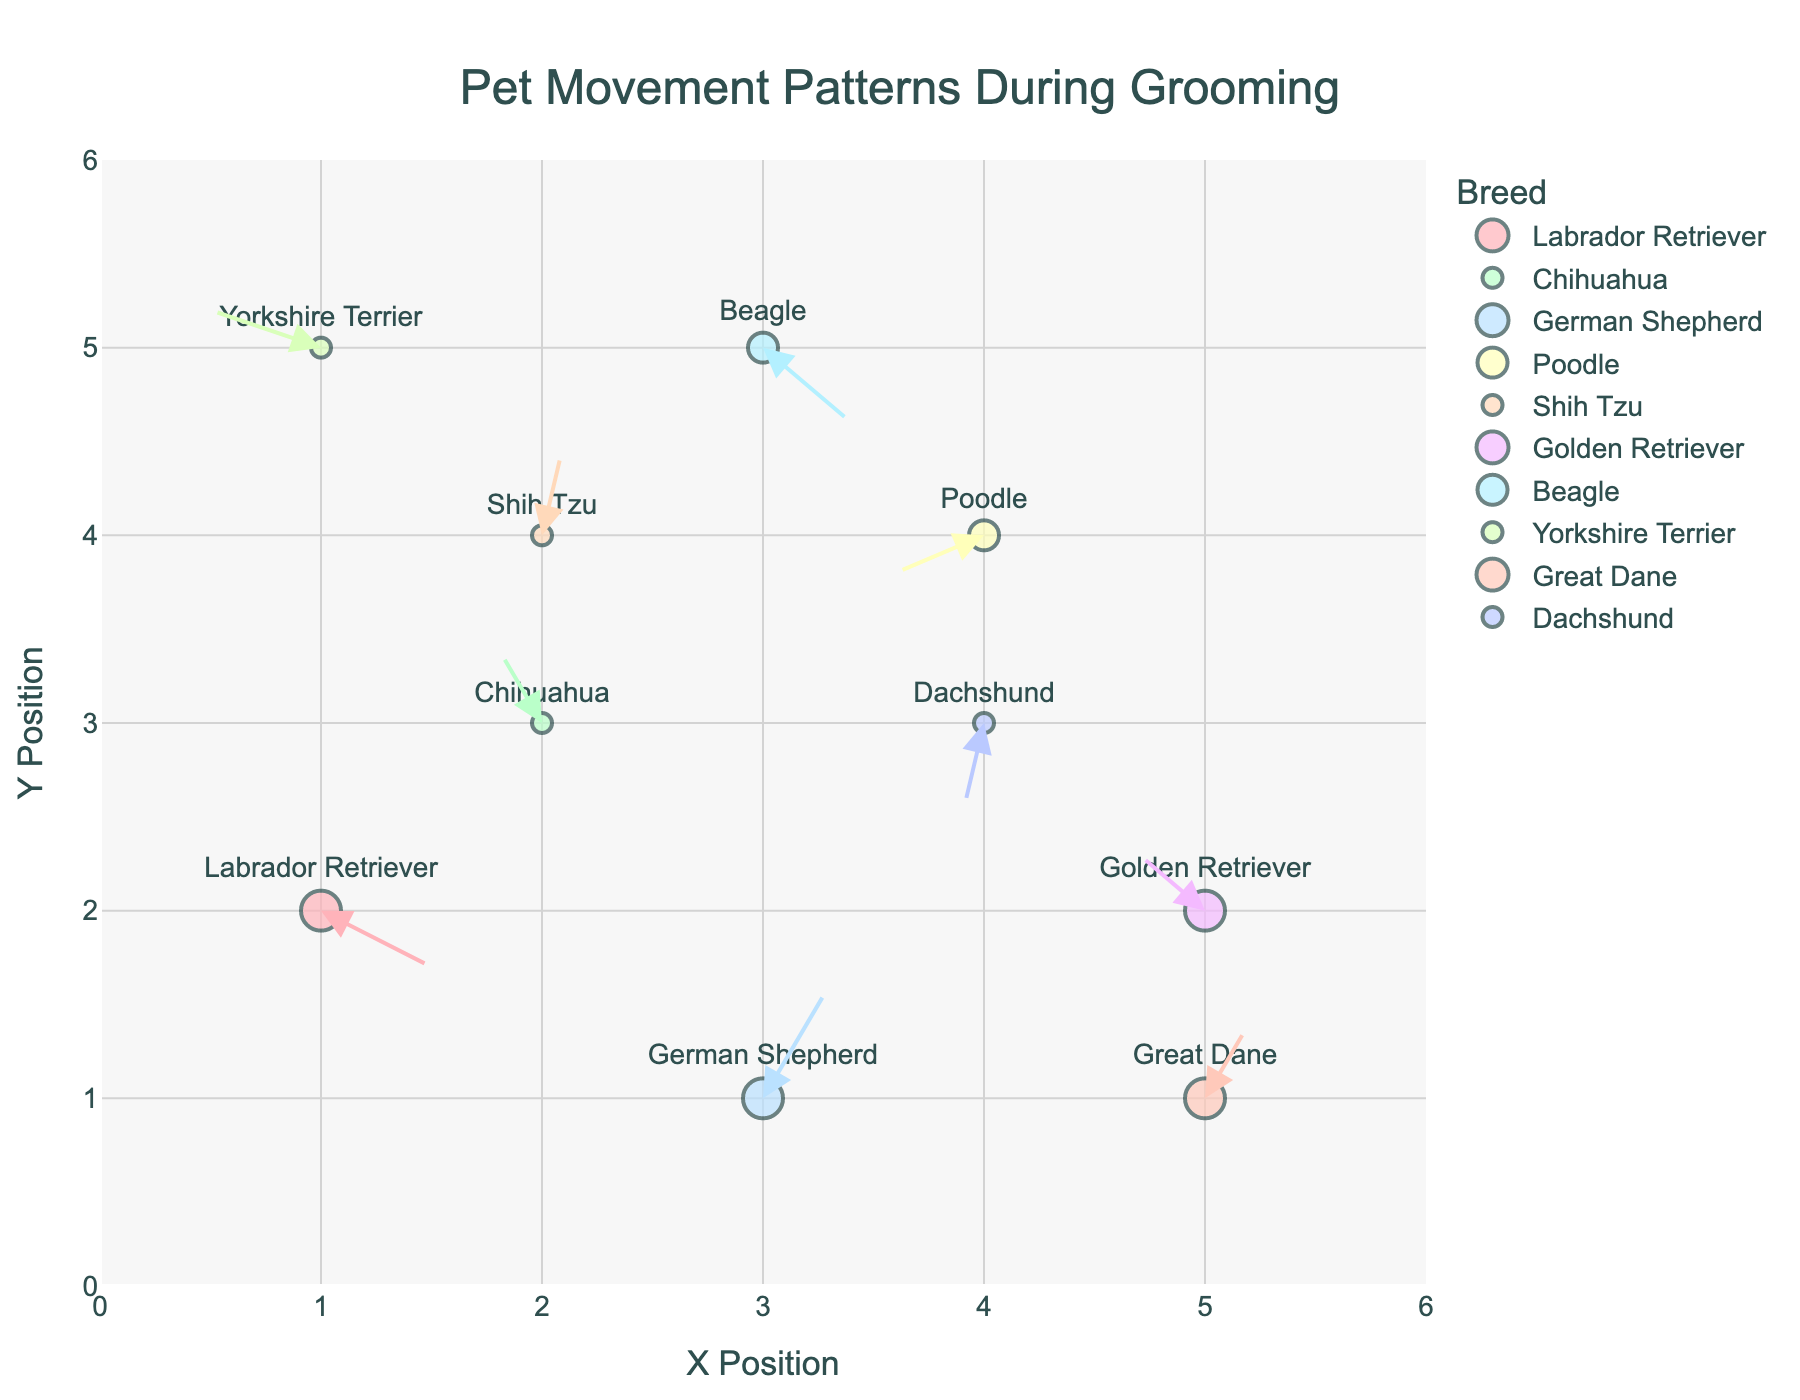How many breeds are represented in the plot? The figure includes a legend that lists each breed, and there are distinct colors for each breed. Counting the unique breeds listed in the legend gives us this answer.
Answer: 10 Which breed has the largest marker size and what is it? In the figure, the marker sizes correspond to pet sizes (Small, Medium, Large). The legend shows different sizes and the breed associated with each size. The breed with the largest marker size, corresponding to "Large", needs to be identified.
Answer: Labrador Retriever, German Shepherd, Golden Retriever, Great Dane What is the movement pattern of the Shih Tzu from its initial position? Locate the Shih Tzu on the plot marked with its breed name. From the initial position, trace the quiver arrow to see its endpoint direction and distance. This will reveal the movement pattern.
Answer: (2, 4) to (2.1, 4.5) Which breed shows the least movement, and how can you tell? By looking at the length of quiver arrows for each breed, the breed with the shortest arrow indicates the least movement. Measure or visually compare the sizes of arrows.
Answer: Dachshund Which breeds are positioned at coordinate (5, 2) and (5, 1)? Locate the coordinates (5, 2) and (5, 1) on the X and Y axes in the plot. Identify which breeds are marked at these positions.
Answer: Golden Retriever at (5, 2) and Great Dane at (5, 1) How many distinct points do pets start from in the plot? Each data point is represented by a unique marker on the plot. Count the individual markers to find the total number of distinct starting points.
Answer: 10 Compare the movement direction of the Chihuahua and the Beagle; how do they differ? Find the initial positions of the Chihuahua and Beagle on the plot. Trace their movement arrows to identify their directions and compare them.
Answer: Chihuahua moves up-right, Beagle moves down-left What is the combined movement vector for the German Shepherd and the Great Dane? Identify the initial coordinates and movement vectors for both breeds. Add their vector components (u, v) to get the combined vector. German Shepherd: (3, 1) + (0.3, 0.6); Great Dane: (5, 1) + (0.2, 0.4). Combined vector: (0.3 + 0.2, 0.6 + 0.4) = (0.5, 1.0).
Answer: (0.5, 1.0) Which breed has movement mostly in the negative Y direction? Trace the quiver arrows for each breed and identify those with arrows predominantly pointing down, indicative of a negative Y direction. Verify by exact arrow endpoints.
Answer: Labrador Retriever 